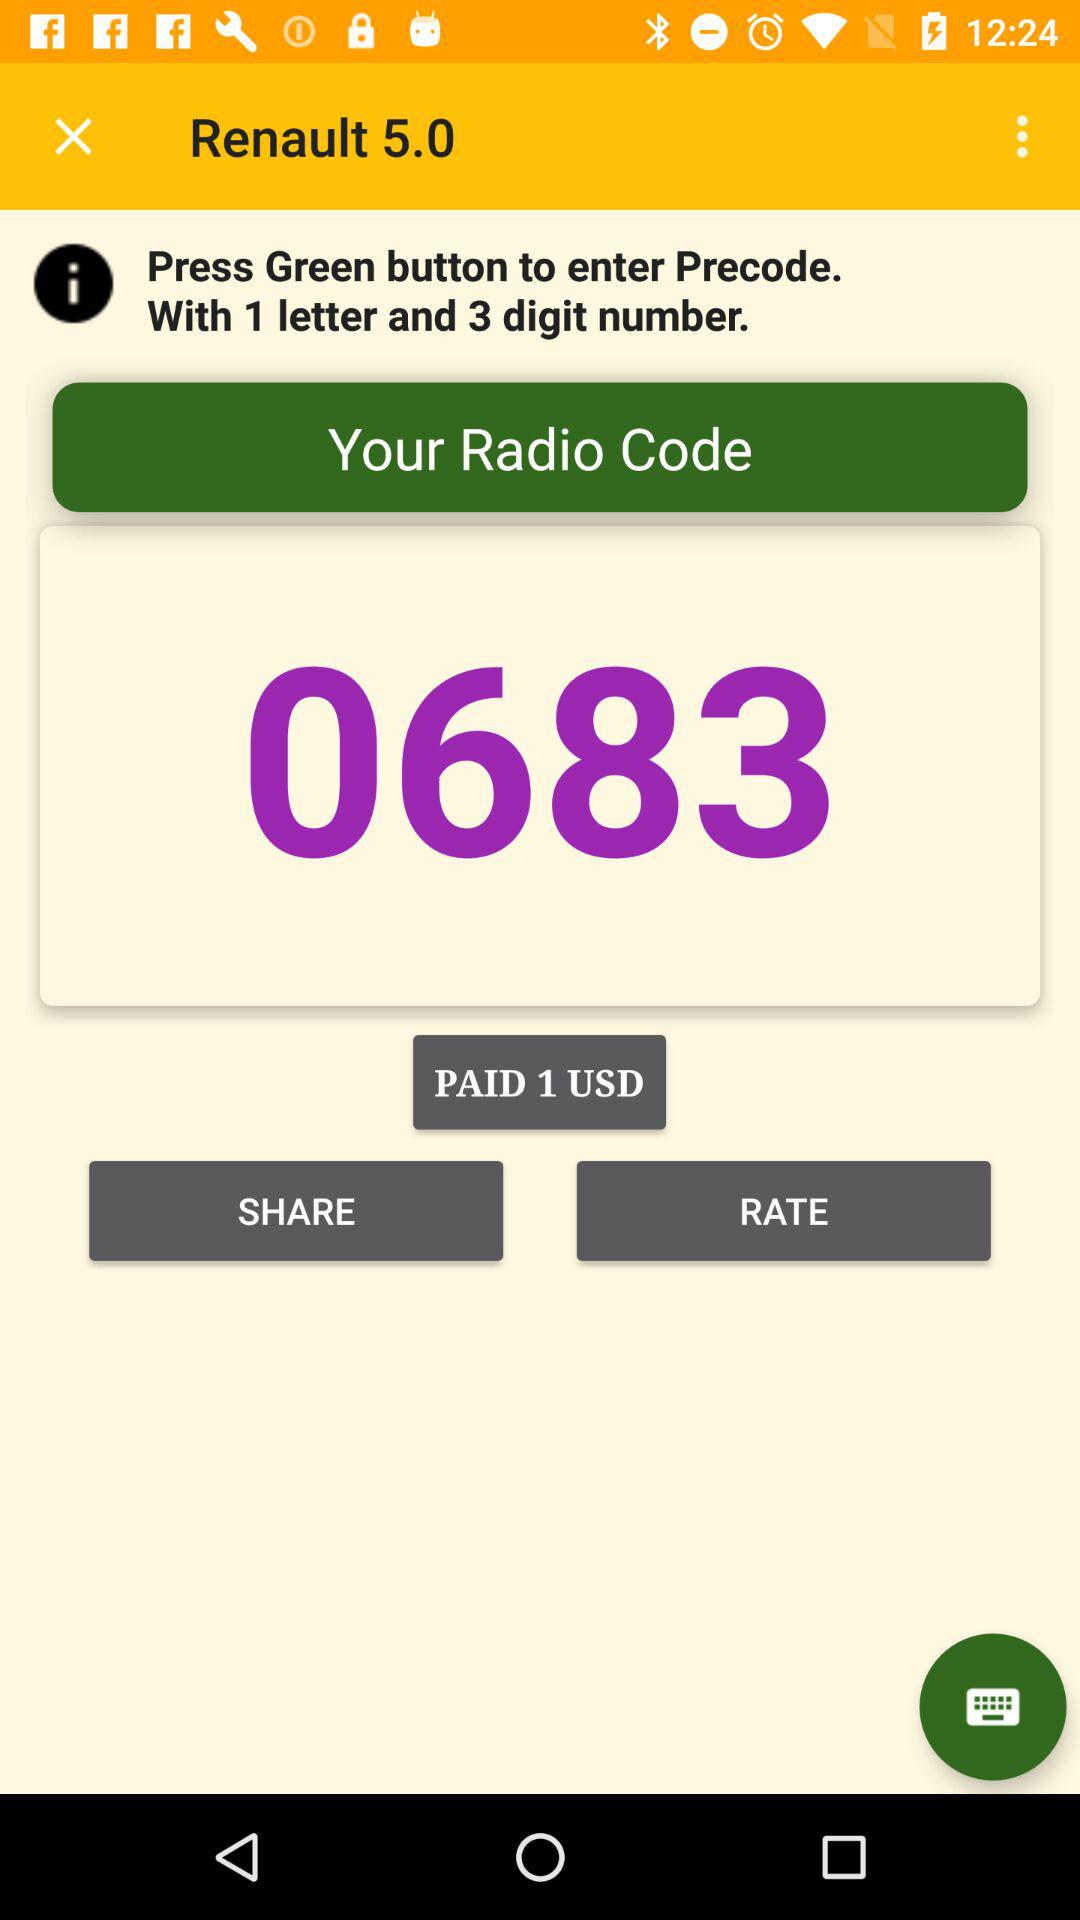What is my radio code? Your radio code is 0683. 